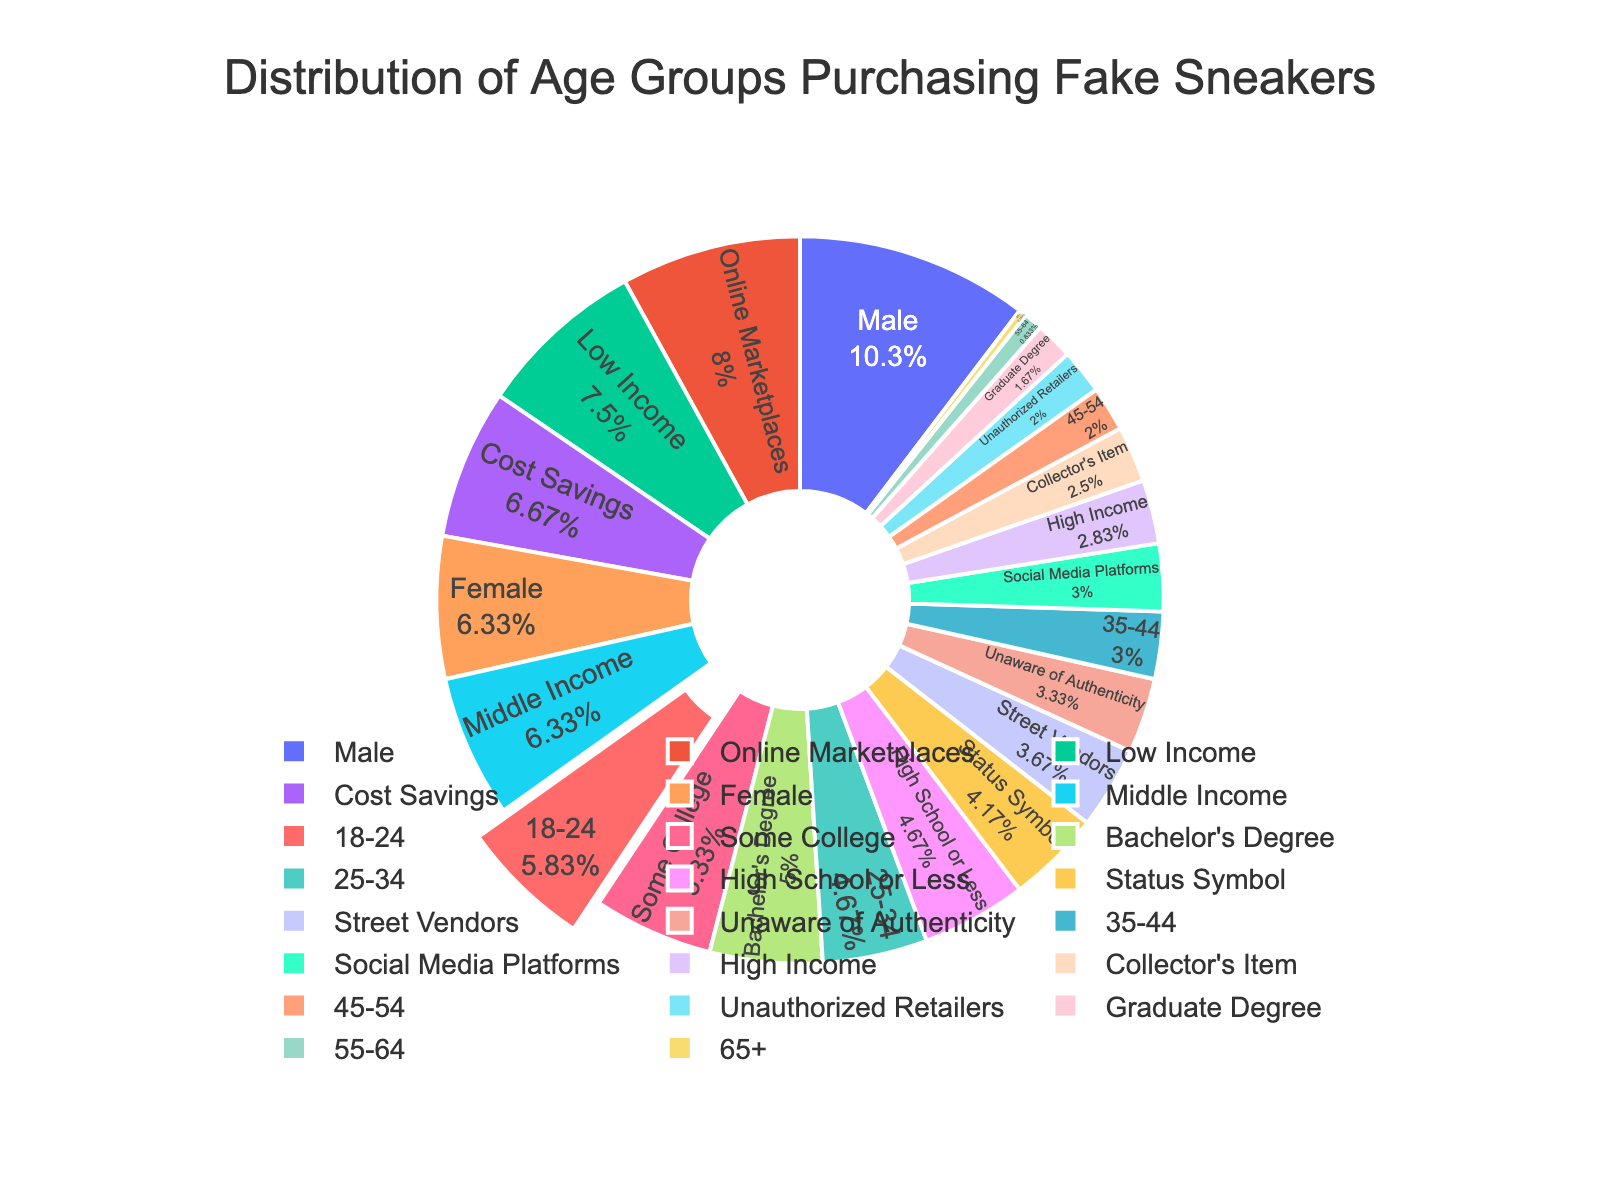What age group has the largest percentage of consumers purchasing fake sneakers? The age group 18-24 has the largest share in the pie chart, as indicated by the biggest slice.
Answer: 18-24 How much larger is the percentage of consumers aged 18-24 compared to those aged 25-34? The percentage for 18-24 is 35%, and the percentage for 25-34 is 28%. The difference is 35% - 28% = 7%.
Answer: 7% What is the combined percentage of consumers aged 35-44 and 45-54? Add the percentages of the two age groups: 18% (35-44) + 12% (45-54) = 30%.
Answer: 30% Which age group has the smallest percentage of consumers purchasing fake sneakers? The age group 65+ has the smallest share, represented by the smallest slice of 2%.
Answer: 65+ Are there more consumers aged 18-24 or those aged 55 and above? Consumers aged 18-24 have a percentage of 35%, while consumers aged 55-64 and 65+ collectively have 5% + 2% = 7%. Thus, there are more consumers aged 18-24.
Answer: 18-24 What is the percentage difference between consumers aged 45-54 and 55-64? Subtract the percentage of the 55-64 age group from the 45-54 age group: 12% - 5% = 7%.
Answer: 7% Which age groups collectively constitute more than half of all consumers? The age groups 18-24 (35%) and 25-34 (28%) collectively constitute 35% + 28% = 63%, which is more than half.
Answer: 18-24 and 25-34 How many age groups have a percentage below 20%? The age groups 35-44 (18%), 45-54 (12%), 55-64 (5%), and 65+ (2%) all have percentages below 20%, making a total of four age groups.
Answer: 4 By how much does the percentage of consumers aged 25-34 exceed those aged 35-44? The percentage for 25-34 is 28%, and for 35-44 it is 18%. The difference is 28% - 18% = 10%.
Answer: 10% Which age groups have a combined contribution of less than a quarter of the total percentage? The age groups 55-64 (5%) and 65+ (2%) together make 5% + 2% = 7%, which is less than a quarter (25%).
Answer: 55-64 and 65+ 